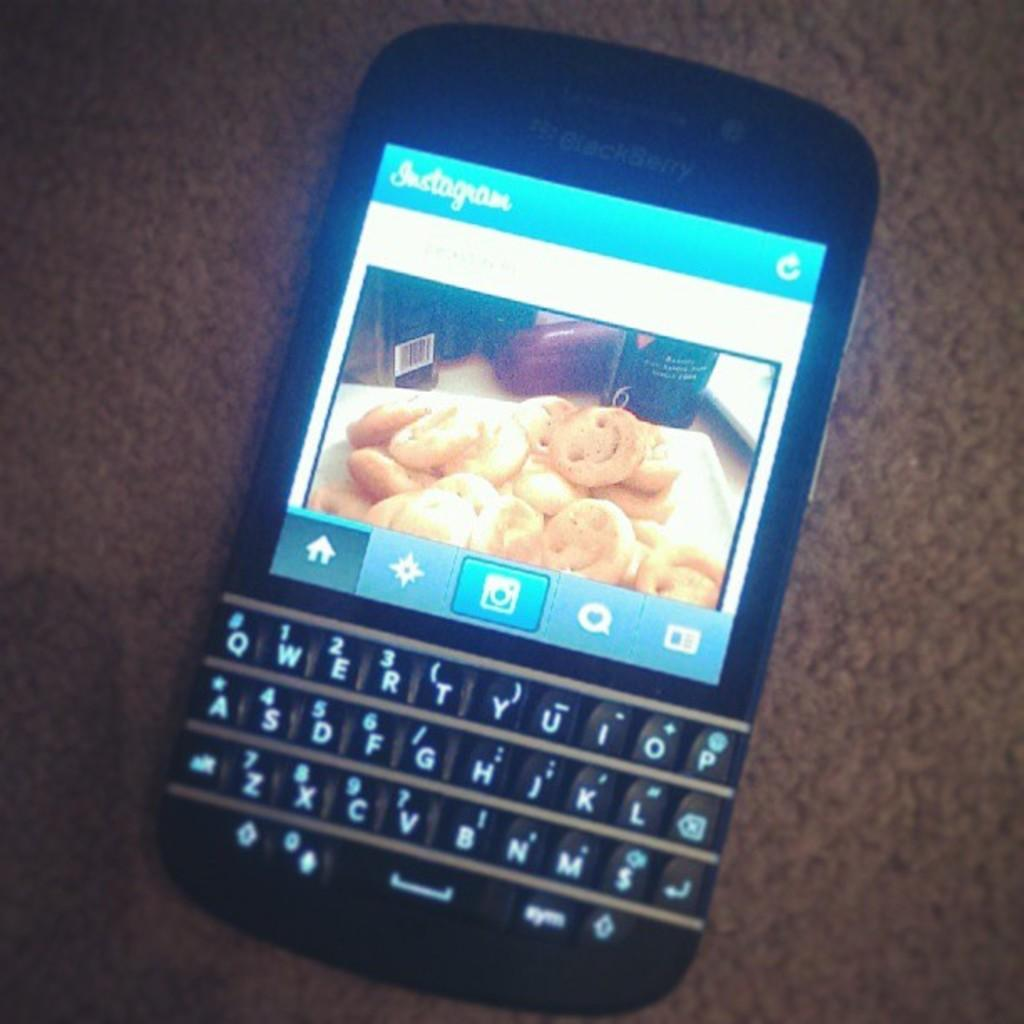<image>
Offer a succinct explanation of the picture presented. A BlackBerry phone is showing an Instagram page on the screen 